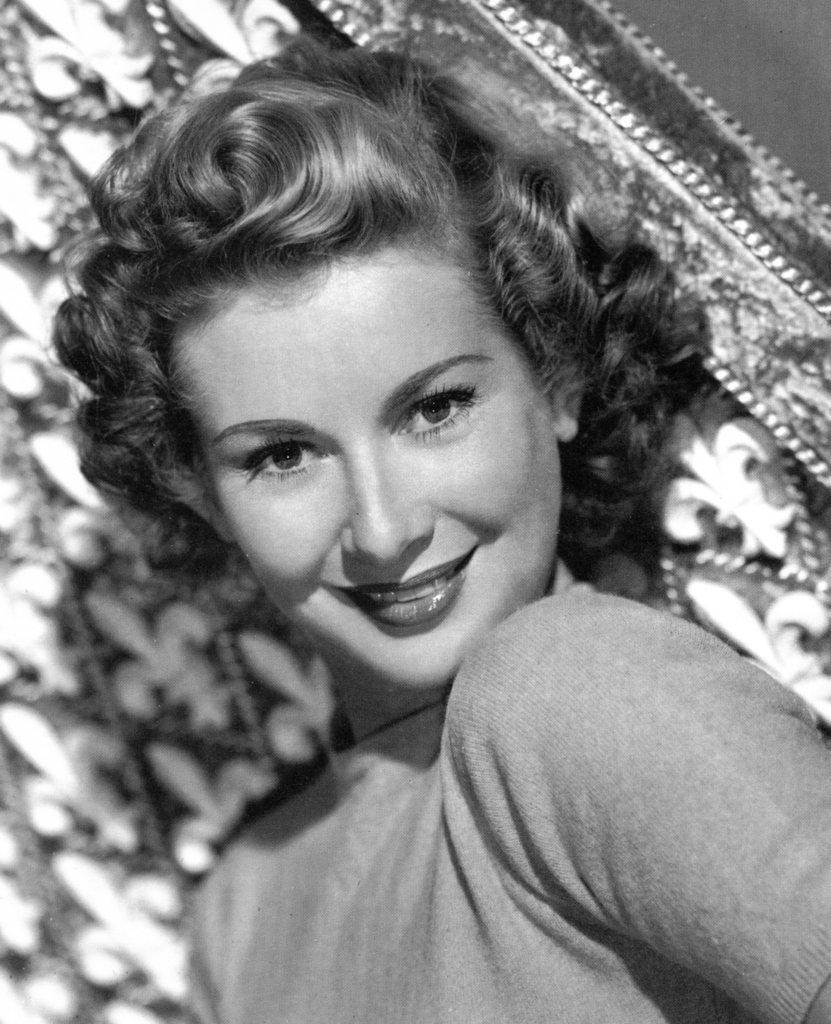In one or two sentences, can you explain what this image depicts? There is a picture of a woman present in the middle of this image and there is a cloth in the background. 